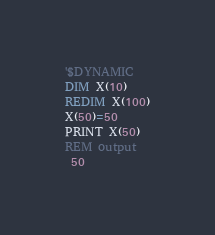Convert code to text. <code><loc_0><loc_0><loc_500><loc_500><_VisualBasic_>'$DYNAMIC
DIM X(10)
REDIM X(100)
X(50)=50
PRINT X(50)
REM output
 50 </code> 